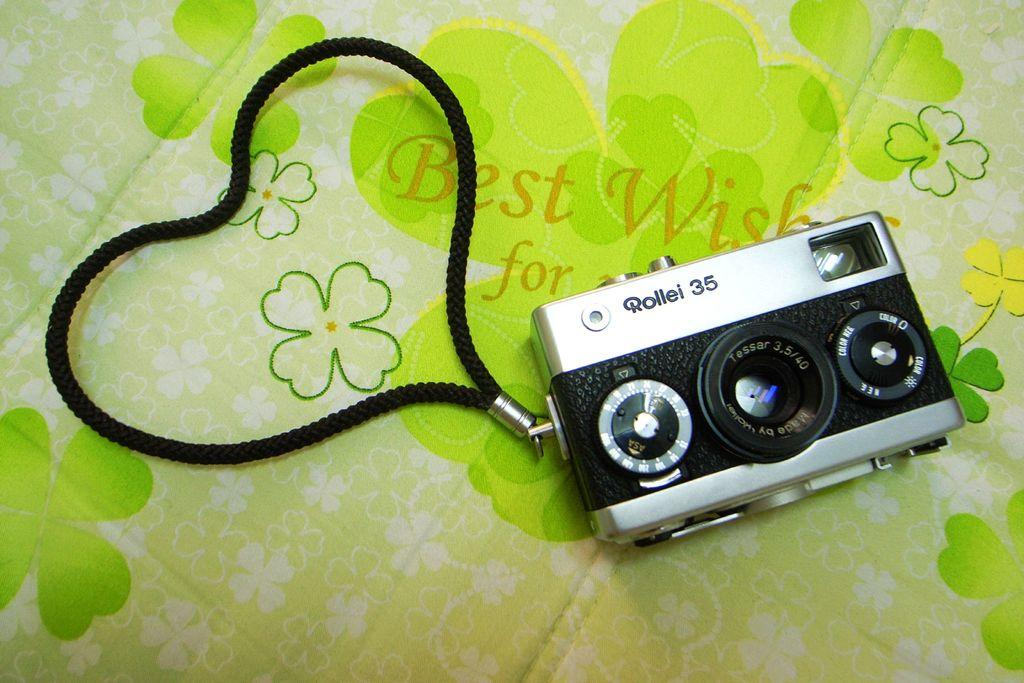<image>
Summarize the visual content of the image. A vintage Rollei 35 film camera with a wrist strap. 